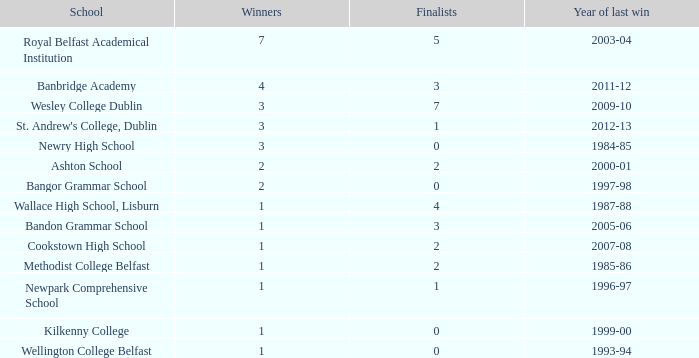What the name of  the school where the last win in 2007-08? Cookstown High School. 